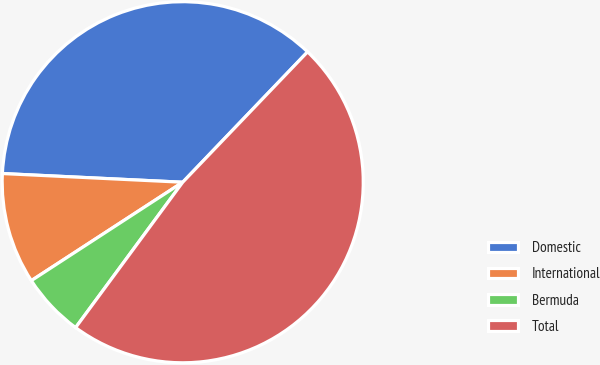Convert chart to OTSL. <chart><loc_0><loc_0><loc_500><loc_500><pie_chart><fcel>Domestic<fcel>International<fcel>Bermuda<fcel>Total<nl><fcel>36.39%<fcel>9.94%<fcel>5.72%<fcel>47.95%<nl></chart> 